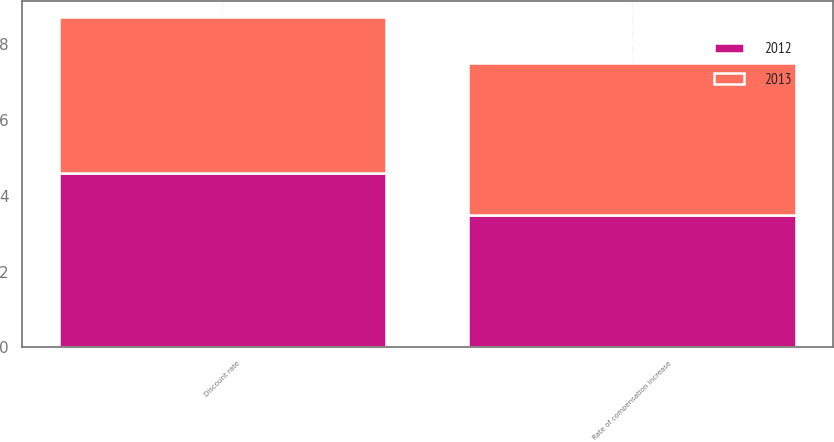<chart> <loc_0><loc_0><loc_500><loc_500><stacked_bar_chart><ecel><fcel>Discount rate<fcel>Rate of compensation increase<nl><fcel>2012<fcel>4.6<fcel>3.5<nl><fcel>2013<fcel>4.1<fcel>4<nl></chart> 